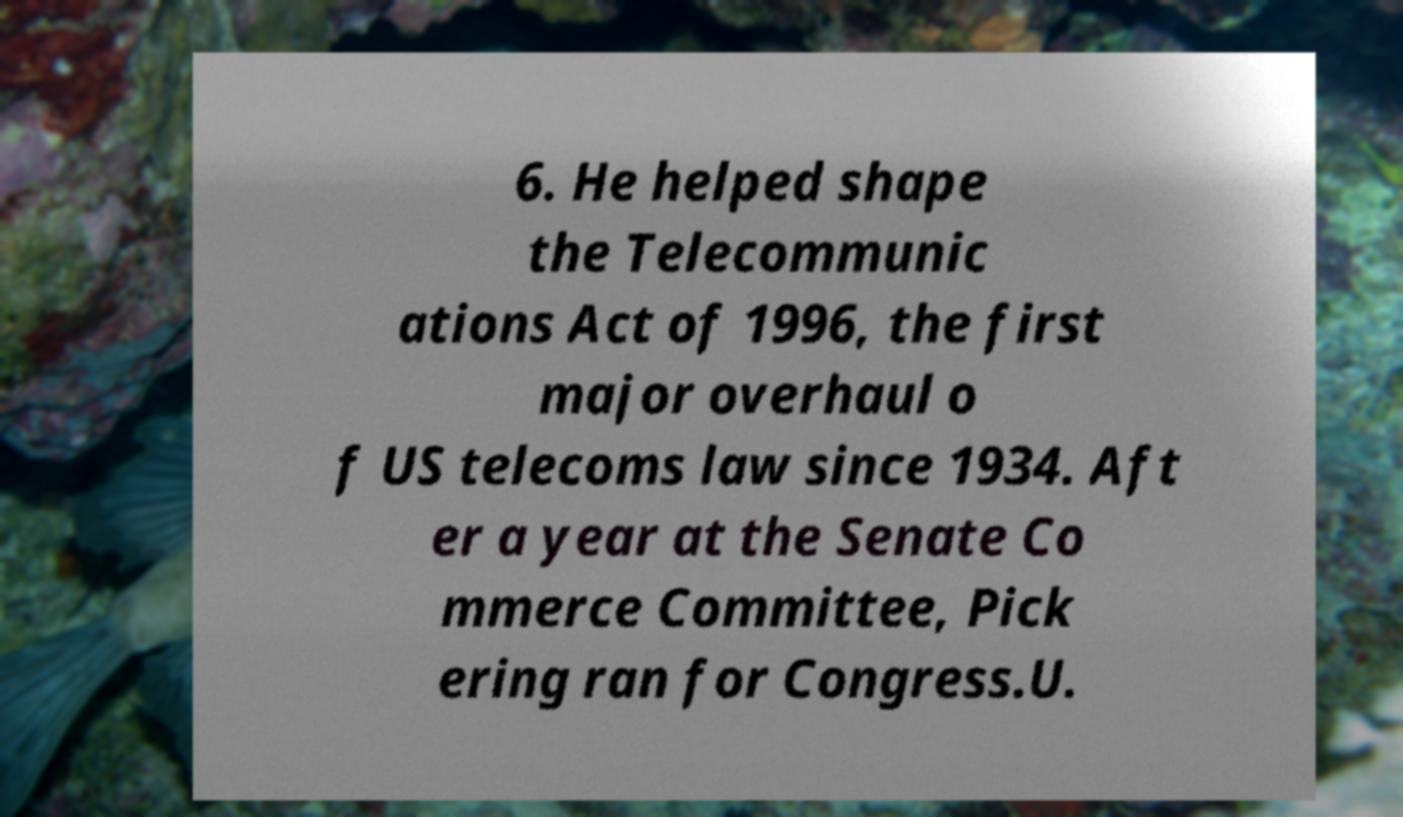Could you extract and type out the text from this image? 6. He helped shape the Telecommunic ations Act of 1996, the first major overhaul o f US telecoms law since 1934. Aft er a year at the Senate Co mmerce Committee, Pick ering ran for Congress.U. 